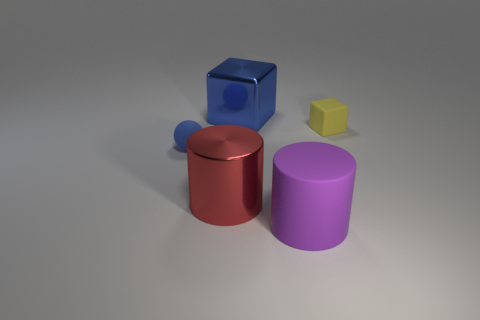Add 1 big purple cylinders. How many objects exist? 6 Subtract all cylinders. How many objects are left? 3 Add 2 blue metal blocks. How many blue metal blocks exist? 3 Subtract 1 red cylinders. How many objects are left? 4 Subtract all large purple things. Subtract all cyan matte things. How many objects are left? 4 Add 3 purple cylinders. How many purple cylinders are left? 4 